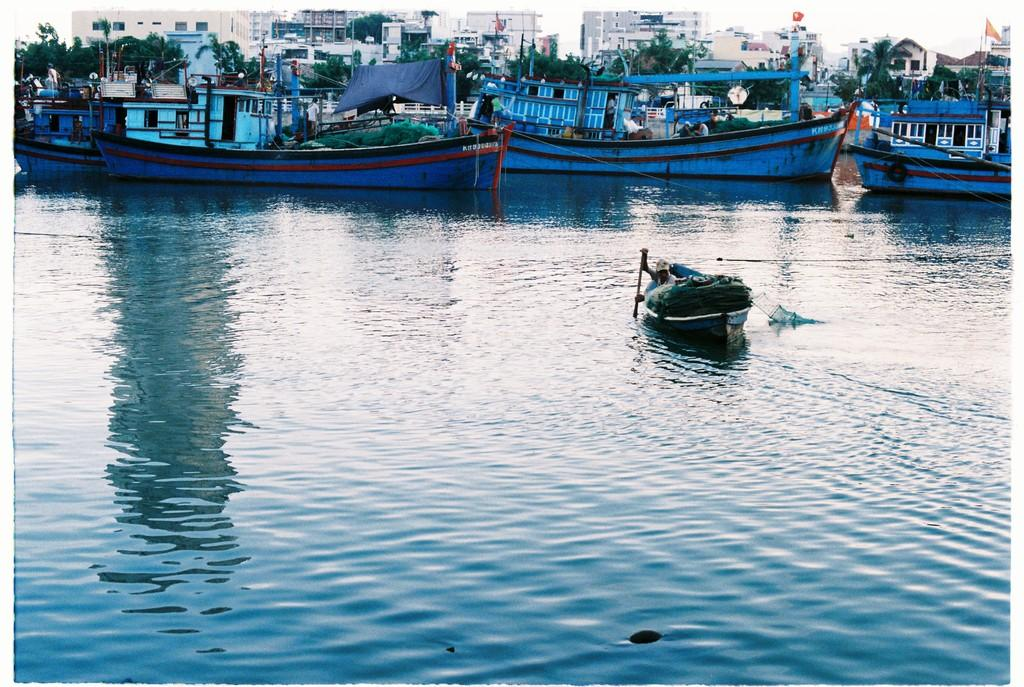What is the primary element visible in the image? There is water in the image. What type of vehicles are present in the water? There are boats in the image. What can be seen in the background of the image? There are trees and buildings in the background of the image. What is the person on the boat doing? One person on a boat is holding a paddle. What type of juice can be seen being squeezed from the trees in the image? There is no juice being squeezed from the trees in the image; the trees are simply part of the background. How many adjustments does the bike in the image need to be fully functional? There is no bike present in the image, so it is not possible to determine how many adjustments it might need. 